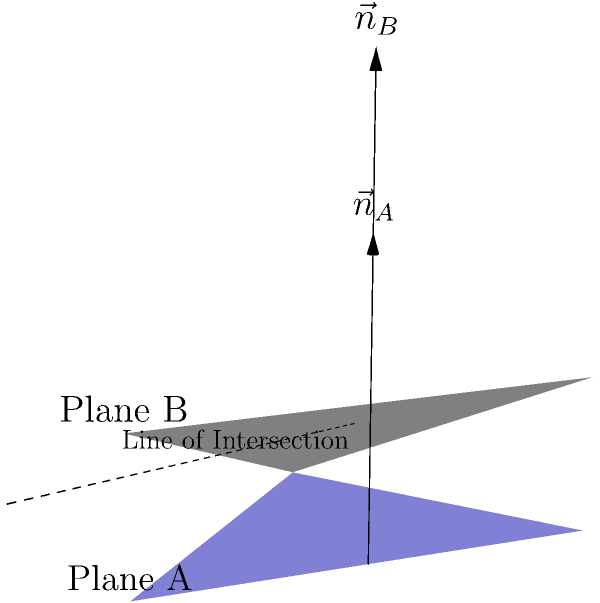As a filmmaker setting up a complex shot, you're working with two studio backdrops represented by Plane A and Plane B in the diagram. The normal vector to Plane A is $\vec{n}_A = (0,0,1)$, and the normal vector to Plane B is $\vec{n}_B = (1,0,2)$. What is the acute angle between these two planes? To find the angle between two planes, we can use the dot product of their normal vectors. The formula is:

$$\cos \theta = \frac{|\vec{n}_A \cdot \vec{n}_B|}{|\vec{n}_A| |\vec{n}_B|}$$

Where $\theta$ is the angle between the planes.

Step 1: Calculate the dot product of the normal vectors:
$\vec{n}_A \cdot \vec{n}_B = (0)(1) + (0)(0) + (1)(2) = 2$

Step 2: Calculate the magnitudes of the normal vectors:
$|\vec{n}_A| = \sqrt{0^2 + 0^2 + 1^2} = 1$
$|\vec{n}_B| = \sqrt{1^2 + 0^2 + 2^2} = \sqrt{5}$

Step 3: Apply the formula:
$$\cos \theta = \frac{|2|}{(1)(\sqrt{5})} = \frac{2}{\sqrt{5}}$$

Step 4: Take the inverse cosine (arccos) of both sides:
$$\theta = \arccos(\frac{2}{\sqrt{5}})$$

Step 5: Calculate the result:
$$\theta \approx 63.4^\circ$$

This is the acute angle between the two planes.
Answer: $63.4^\circ$ 